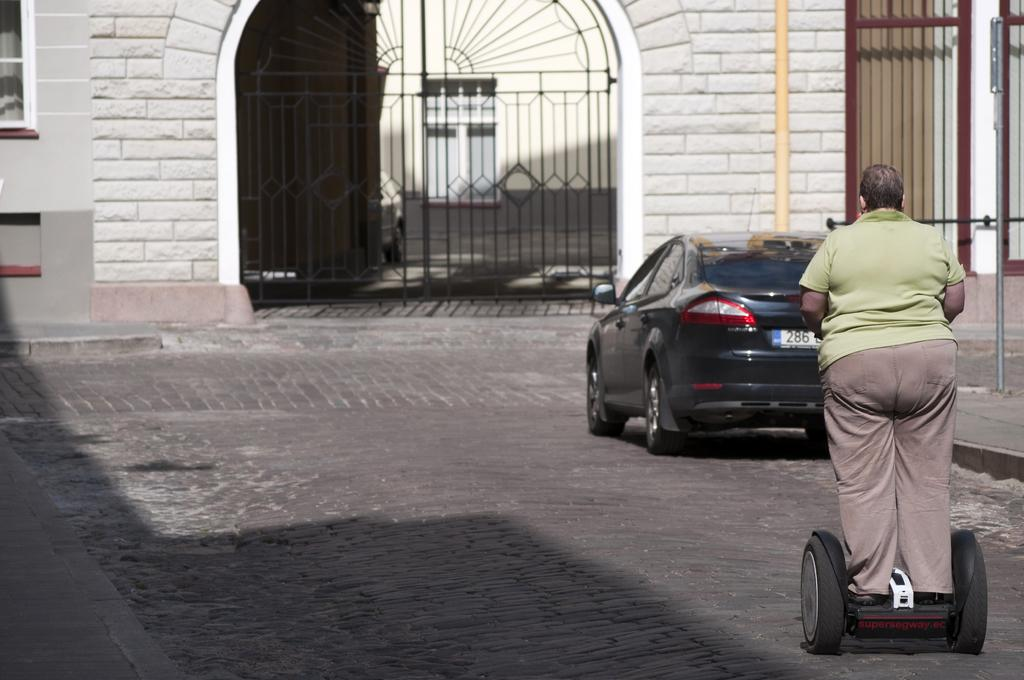What is the person in the image using to travel? The person is standing on a hoverboard in the image. What type of vehicle can be seen on the road in the image? There is a car on the road in the image. What structures are visible in the image? There are poles, a gate, and a wall visible in the image. What architectural feature allows for light and air to enter the building in the image? There are windows in the image. What type of space patch can be seen on the person's hoverboard in the image? There is no space patch present on the person's hoverboard in the image. How does the person on the hoverboard express their feelings of hate towards the car in the image? There is no indication of hate or any emotions in the image; the person is simply standing on a hoverboard. 